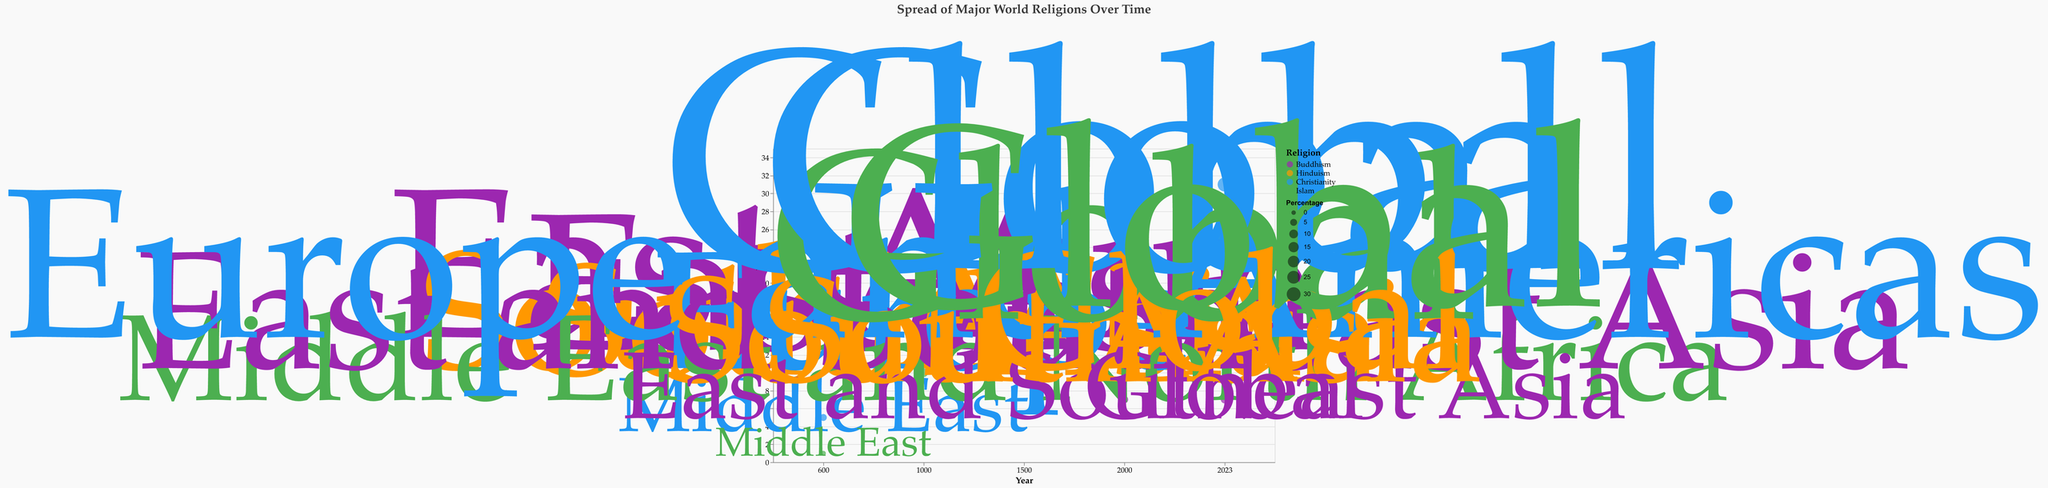How has the global percentage of Christians changed from 2000 to 2023? In 2000, the global percentage of Christians was 31%. In 2023, it remained at 31%. Therefore, the percentage has not changed.
Answer: 0% What region had the highest percentage of Buddhists in 1500? In 1500, the region with the highest percentage of Buddhists was East and Southeast Asia with 15%.
Answer: East and Southeast Asia How does the percentage of Muslims in 2023 compare to the percentage in 600? In 600, the percentage of Muslims was 1%. In 2023, it increased to 25%. The percentage increased by 24%.
Answer: 24% What is the sum of the percentages of Hinduism and Buddhism in East Asia in 1000? The percentage of Hinduism in 1000 in South Asia was 14%, and the percentage of Buddhism in 1000 in East Asia was 18%. The sum is 14% + 18% = 32%.
Answer: 32% Which religion had the largest increase in global percentage from 1500 to 2023? Christianity increased from 20% in 1500 to 31% in 2023, an increase of 11%. Hinduism increased from 13% to 15%, a 2% increase. Buddhism decreased from 15% to 7%, an 8% decrease. Islam increased from 10% to 25%, a 15% increase. Islam had the largest increase.
Answer: Islam In which year did Christianity first become a globally prominent religion, according to the figure? Christianity became globally prominent in 2000 with a percentage of 31%. Before that, in 1500, it was predominantly in Europe and the Americas.
Answer: 2000 What's the difference in the percentage of Buddhism between 1000 and 2023? In 1000, the percentage of Buddhism was 18%. In 2023, it was 7%. The difference is 18% - 7% = 11%.
Answer: 11% Which religions were present in the Middle East in 600 according to the figure, and what were their percentages? In 600, Christianity was at 5%, and Islam was at 1% in the Middle East.
Answer: Christianity: 5%, Islam: 1% How did the regional spread of Islam change from 1000 to 2000? In 1000, Islam was primarily in the Middle East and North Africa with 10%. By 2000, Islam had become global with a percentage of 23%.
Answer: Became global from Middle East and North Africa What is the average percentage of Hinduism from 600 to 2023? Percentages of Hinduism are 15%, 14%, 13%, 13%, and 15% for the years 600, 1000, 1500, 2000, and 2023 respectively. The average is (15 + 14 + 13 + 13 + 15) / 5 = 70 / 5 = 14%.
Answer: 14% 